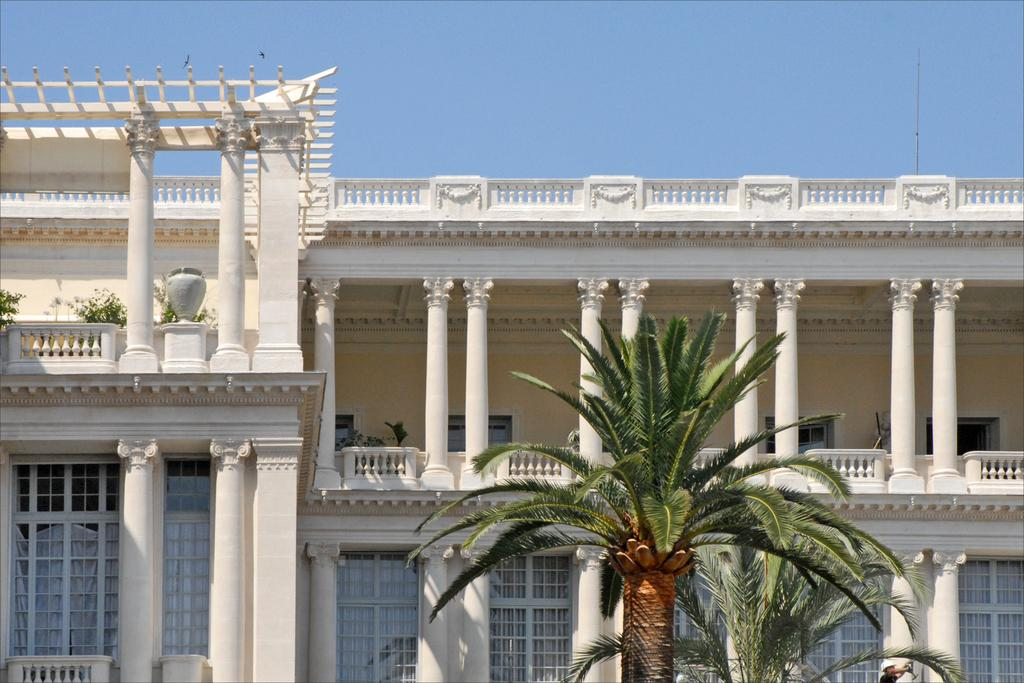What type of natural elements can be seen in the image? There are trees and plants in the image. What type of man-made structure is present in the image? There is a building in the image. Can you describe the person in the image? There is a person in the image. What is visible in the background of the image? The sky is visible in the background of the image. What type of bean is being shaken by the person in the image? There is no bean or shaking activity present in the image. What part of the person's brain can be seen in the image? There is no part of the person's brain visible in the image. 